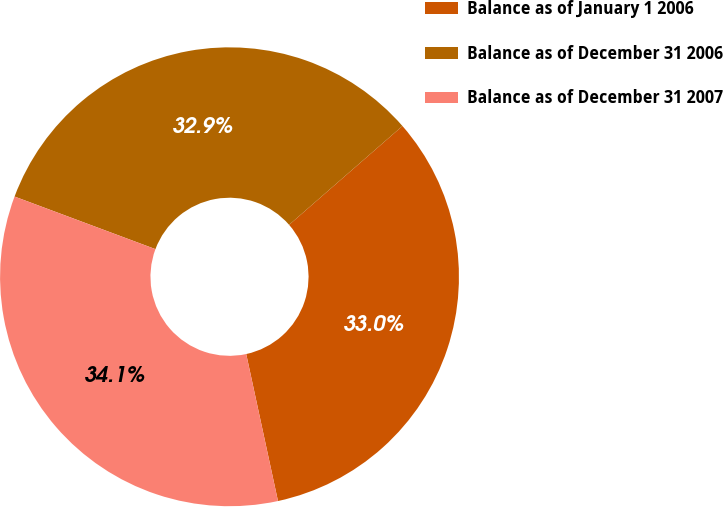<chart> <loc_0><loc_0><loc_500><loc_500><pie_chart><fcel>Balance as of January 1 2006<fcel>Balance as of December 31 2006<fcel>Balance as of December 31 2007<nl><fcel>33.02%<fcel>32.9%<fcel>34.07%<nl></chart> 